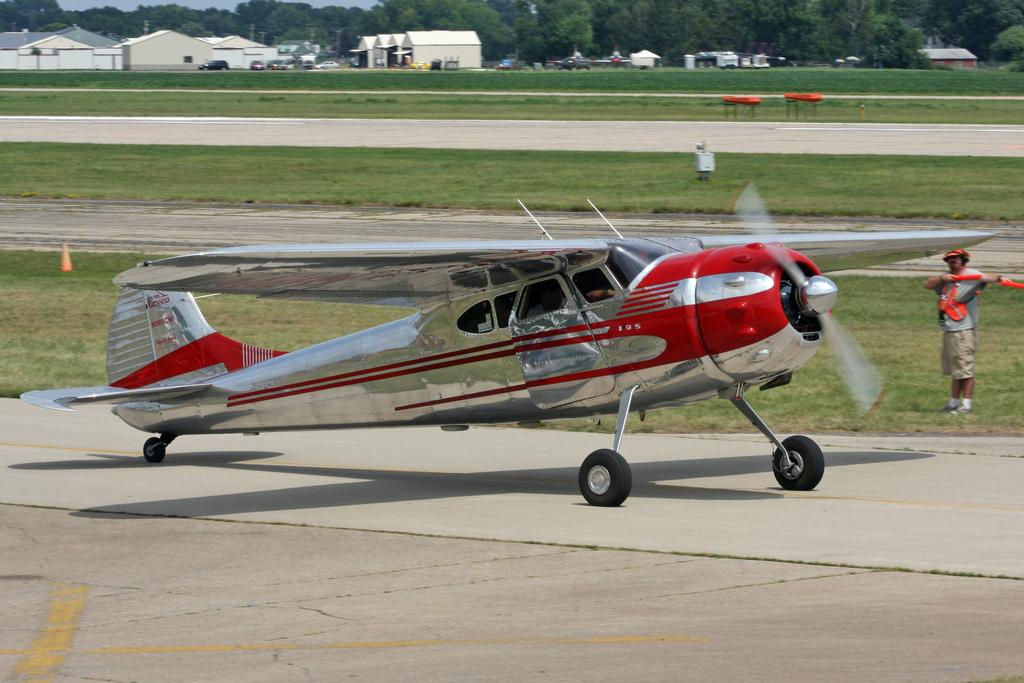What is the main subject of the image? The main subject of the image is an airplane. Can you describe the person in the image? There is a person standing in the image. What type of structures can be seen in the image? There are houses in the image. What type of vegetation is present in the image? There are trees and grass in the image. How many cacti are visible in the image? There are no cacti present in the image. What type of day is it in the image? The provided facts do not give any information about the time of day or weather conditions in the image. 